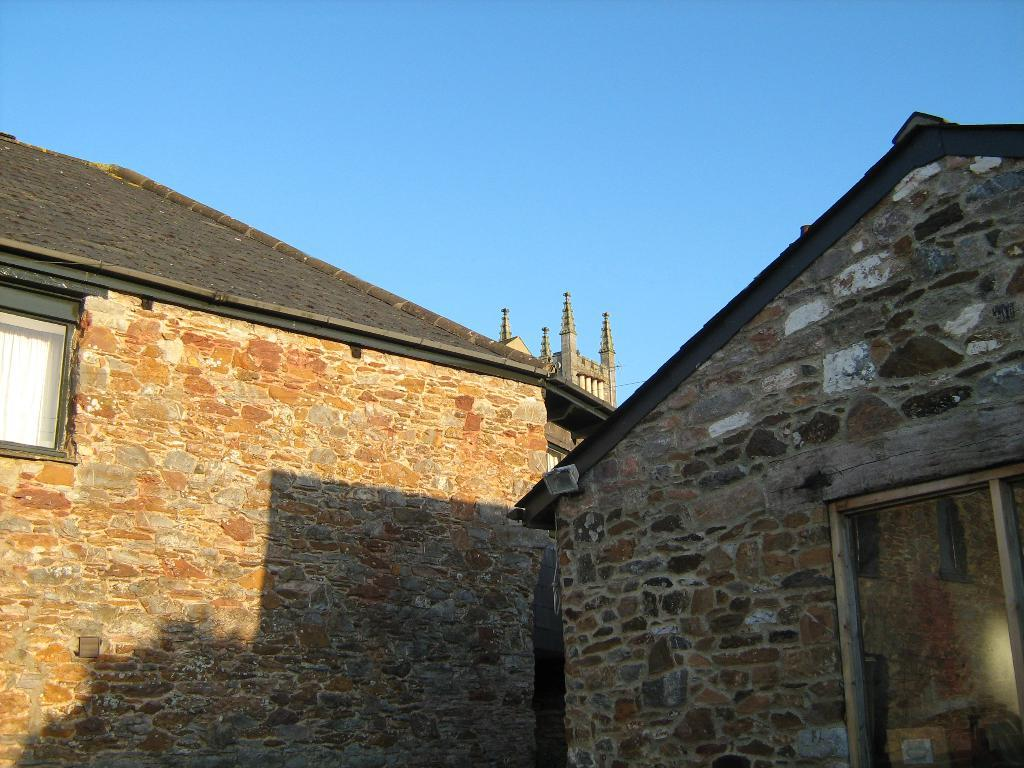What type of structures are present in the image? There are buildings in the image. What feature can be seen on the buildings? The buildings have windows. What can be seen in the distance in the image? The sky is visible in the background of the image. Can you tell me how many cards the beggar is holding in the image? There is no beggar or card present in the image. What type of guide is featured in the image? There is no guide present in the image. 